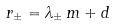<formula> <loc_0><loc_0><loc_500><loc_500>r _ { \pm } = \lambda _ { \pm } \, m + d</formula> 